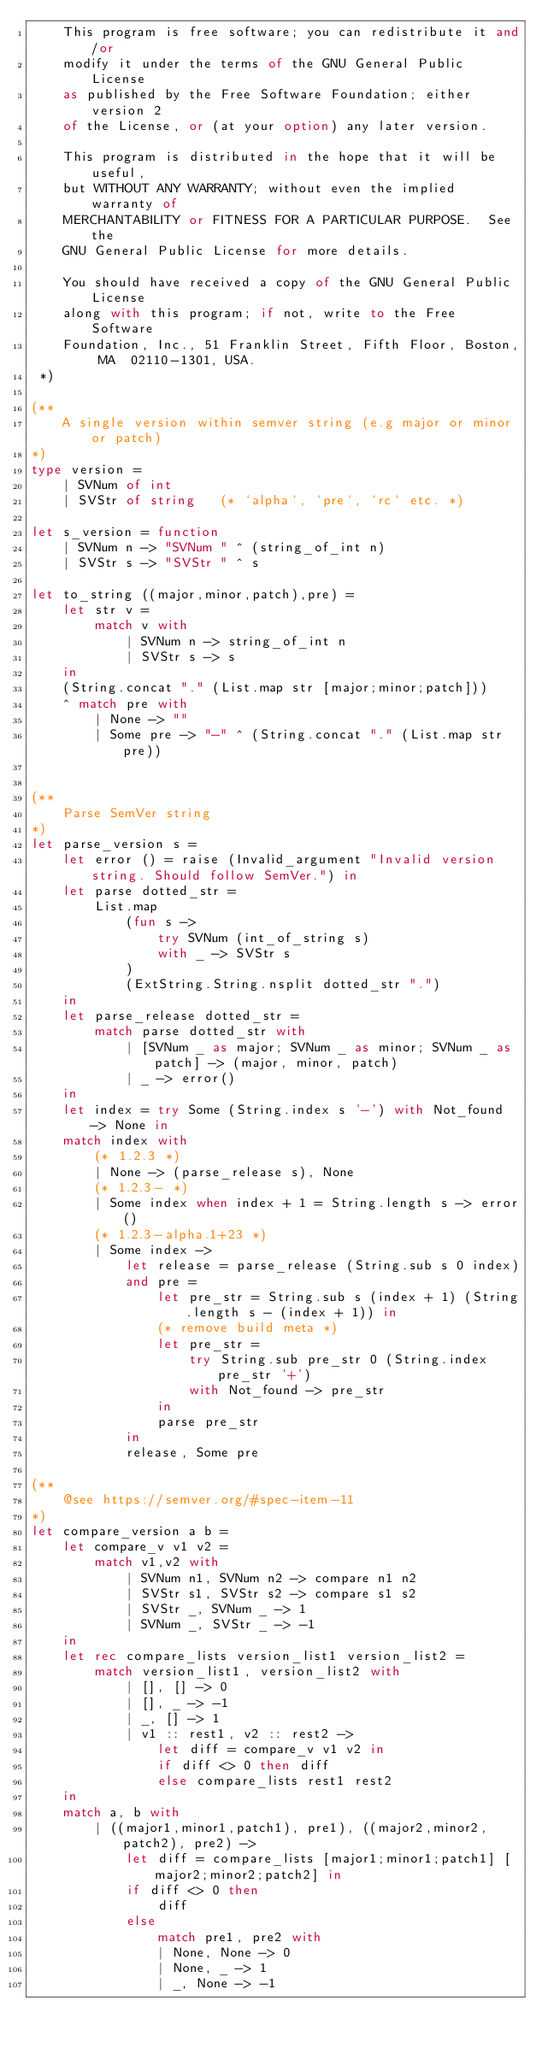<code> <loc_0><loc_0><loc_500><loc_500><_OCaml_>	This program is free software; you can redistribute it and/or
	modify it under the terms of the GNU General Public License
	as published by the Free Software Foundation; either version 2
	of the License, or (at your option) any later version.

	This program is distributed in the hope that it will be useful,
	but WITHOUT ANY WARRANTY; without even the implied warranty of
	MERCHANTABILITY or FITNESS FOR A PARTICULAR PURPOSE.  See the
	GNU General Public License for more details.

	You should have received a copy of the GNU General Public License
	along with this program; if not, write to the Free Software
	Foundation, Inc., 51 Franklin Street, Fifth Floor, Boston, MA  02110-1301, USA.
 *)

(**
	A single version within semver string (e.g major or minor or patch)
*)
type version =
	| SVNum of int
	| SVStr of string	(* `alpha`, `pre`, `rc` etc. *)

let s_version = function
	| SVNum n -> "SVNum " ^ (string_of_int n)
	| SVStr s -> "SVStr " ^ s

let to_string ((major,minor,patch),pre) =
	let str v =
		match v with
			| SVNum n -> string_of_int n
			| SVStr s -> s
	in
	(String.concat "." (List.map str [major;minor;patch]))
	^ match pre with
		| None -> ""
		| Some pre -> "-" ^ (String.concat "." (List.map str pre))


(**
	Parse SemVer string
*)
let parse_version s =
	let error () = raise (Invalid_argument "Invalid version string. Should follow SemVer.") in
	let parse dotted_str =
		List.map
			(fun s ->
				try SVNum (int_of_string s)
				with _ -> SVStr s
			)
			(ExtString.String.nsplit dotted_str ".")
	in
	let parse_release dotted_str =
		match parse dotted_str with
			| [SVNum _ as major; SVNum _ as minor; SVNum _ as patch] -> (major, minor, patch)
			| _ -> error()
	in
	let index = try Some (String.index s '-') with Not_found -> None in
	match index with
		(* 1.2.3 *)
		| None -> (parse_release s), None
		(* 1.2.3- *)
		| Some index when index + 1 = String.length s -> error()
		(* 1.2.3-alpha.1+23 *)
		| Some index ->
			let release = parse_release (String.sub s 0 index)
			and pre =
				let pre_str = String.sub s (index + 1) (String.length s - (index + 1)) in
				(* remove build meta *)
				let pre_str =
					try String.sub pre_str 0 (String.index pre_str '+')
					with Not_found -> pre_str
				in
				parse pre_str
			in
			release, Some pre

(**
	@see https://semver.org/#spec-item-11
*)
let compare_version a b =
	let compare_v v1 v2 =
		match v1,v2 with
			| SVNum n1, SVNum n2 -> compare n1 n2
			| SVStr s1, SVStr s2 -> compare s1 s2
			| SVStr _, SVNum _ -> 1
			| SVNum _, SVStr _ -> -1
	in
	let rec compare_lists version_list1 version_list2 =
		match version_list1, version_list2 with
			| [], [] -> 0
			| [], _ -> -1
			| _, [] -> 1
			| v1 :: rest1, v2 :: rest2 ->
				let diff = compare_v v1 v2 in
				if diff <> 0 then diff
				else compare_lists rest1 rest2
	in
	match a, b with
		| ((major1,minor1,patch1), pre1), ((major2,minor2,patch2), pre2) ->
			let diff = compare_lists [major1;minor1;patch1] [major2;minor2;patch2] in
			if diff <> 0 then
				diff
			else
				match pre1, pre2 with
				| None, None -> 0
				| None, _ -> 1
				| _, None -> -1</code> 